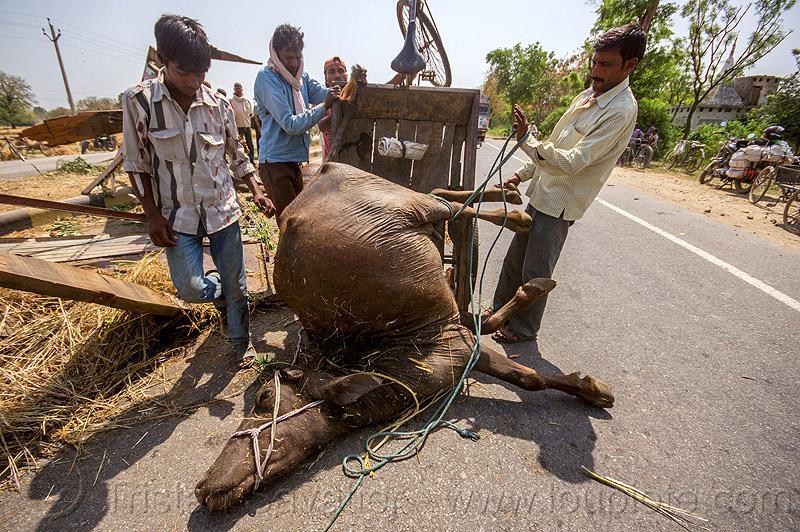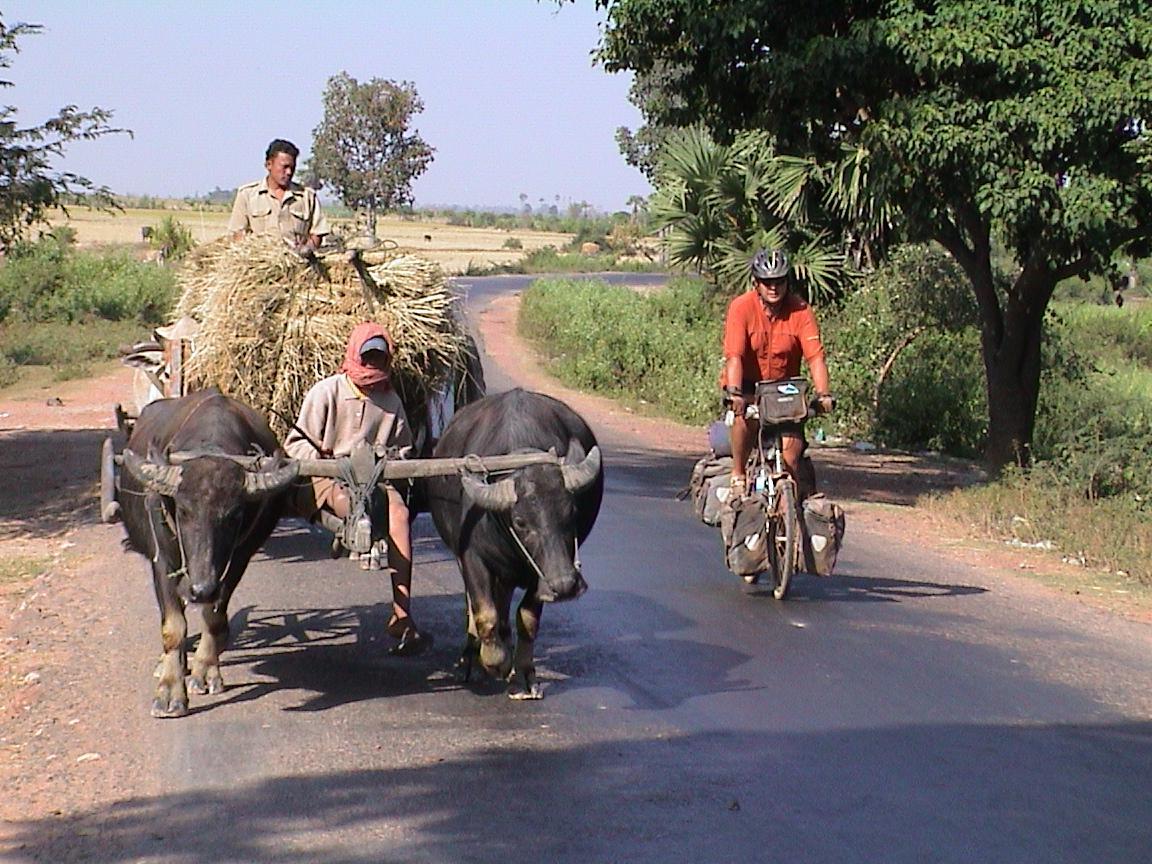The first image is the image on the left, the second image is the image on the right. For the images shown, is this caption "An umbrella hovers over the cart in one of the images." true? Answer yes or no. No. The first image is the image on the left, the second image is the image on the right. Analyze the images presented: Is the assertion "There is an ox in the water." valid? Answer yes or no. No. 